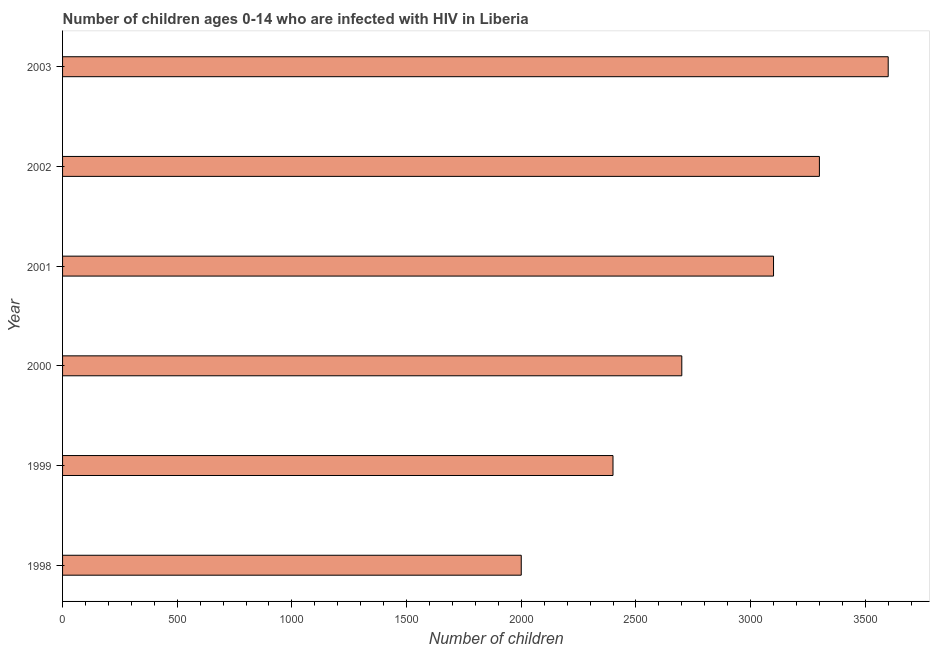Does the graph contain any zero values?
Make the answer very short. No. What is the title of the graph?
Your answer should be very brief. Number of children ages 0-14 who are infected with HIV in Liberia. What is the label or title of the X-axis?
Your answer should be very brief. Number of children. What is the label or title of the Y-axis?
Provide a short and direct response. Year. Across all years, what is the maximum number of children living with hiv?
Offer a terse response. 3600. Across all years, what is the minimum number of children living with hiv?
Offer a terse response. 2000. In which year was the number of children living with hiv maximum?
Keep it short and to the point. 2003. In which year was the number of children living with hiv minimum?
Keep it short and to the point. 1998. What is the sum of the number of children living with hiv?
Keep it short and to the point. 1.71e+04. What is the difference between the number of children living with hiv in 1999 and 2003?
Offer a terse response. -1200. What is the average number of children living with hiv per year?
Keep it short and to the point. 2850. What is the median number of children living with hiv?
Your answer should be compact. 2900. In how many years, is the number of children living with hiv greater than 900 ?
Offer a terse response. 6. Do a majority of the years between 1998 and 2003 (inclusive) have number of children living with hiv greater than 800 ?
Offer a very short reply. Yes. What is the ratio of the number of children living with hiv in 2002 to that in 2003?
Ensure brevity in your answer.  0.92. Is the number of children living with hiv in 1998 less than that in 2001?
Ensure brevity in your answer.  Yes. Is the difference between the number of children living with hiv in 2001 and 2003 greater than the difference between any two years?
Your answer should be compact. No. What is the difference between the highest and the second highest number of children living with hiv?
Your answer should be compact. 300. What is the difference between the highest and the lowest number of children living with hiv?
Your answer should be compact. 1600. How many bars are there?
Provide a short and direct response. 6. Are all the bars in the graph horizontal?
Your answer should be compact. Yes. Are the values on the major ticks of X-axis written in scientific E-notation?
Keep it short and to the point. No. What is the Number of children of 1998?
Ensure brevity in your answer.  2000. What is the Number of children of 1999?
Make the answer very short. 2400. What is the Number of children in 2000?
Keep it short and to the point. 2700. What is the Number of children in 2001?
Ensure brevity in your answer.  3100. What is the Number of children in 2002?
Provide a short and direct response. 3300. What is the Number of children of 2003?
Offer a terse response. 3600. What is the difference between the Number of children in 1998 and 1999?
Offer a very short reply. -400. What is the difference between the Number of children in 1998 and 2000?
Your answer should be very brief. -700. What is the difference between the Number of children in 1998 and 2001?
Offer a very short reply. -1100. What is the difference between the Number of children in 1998 and 2002?
Your answer should be compact. -1300. What is the difference between the Number of children in 1998 and 2003?
Offer a terse response. -1600. What is the difference between the Number of children in 1999 and 2000?
Provide a short and direct response. -300. What is the difference between the Number of children in 1999 and 2001?
Give a very brief answer. -700. What is the difference between the Number of children in 1999 and 2002?
Provide a succinct answer. -900. What is the difference between the Number of children in 1999 and 2003?
Ensure brevity in your answer.  -1200. What is the difference between the Number of children in 2000 and 2001?
Provide a succinct answer. -400. What is the difference between the Number of children in 2000 and 2002?
Give a very brief answer. -600. What is the difference between the Number of children in 2000 and 2003?
Provide a succinct answer. -900. What is the difference between the Number of children in 2001 and 2002?
Offer a very short reply. -200. What is the difference between the Number of children in 2001 and 2003?
Your response must be concise. -500. What is the difference between the Number of children in 2002 and 2003?
Your answer should be very brief. -300. What is the ratio of the Number of children in 1998 to that in 1999?
Keep it short and to the point. 0.83. What is the ratio of the Number of children in 1998 to that in 2000?
Offer a very short reply. 0.74. What is the ratio of the Number of children in 1998 to that in 2001?
Your answer should be compact. 0.65. What is the ratio of the Number of children in 1998 to that in 2002?
Offer a terse response. 0.61. What is the ratio of the Number of children in 1998 to that in 2003?
Your answer should be compact. 0.56. What is the ratio of the Number of children in 1999 to that in 2000?
Offer a terse response. 0.89. What is the ratio of the Number of children in 1999 to that in 2001?
Keep it short and to the point. 0.77. What is the ratio of the Number of children in 1999 to that in 2002?
Make the answer very short. 0.73. What is the ratio of the Number of children in 1999 to that in 2003?
Your answer should be compact. 0.67. What is the ratio of the Number of children in 2000 to that in 2001?
Your response must be concise. 0.87. What is the ratio of the Number of children in 2000 to that in 2002?
Your answer should be compact. 0.82. What is the ratio of the Number of children in 2000 to that in 2003?
Offer a very short reply. 0.75. What is the ratio of the Number of children in 2001 to that in 2002?
Provide a short and direct response. 0.94. What is the ratio of the Number of children in 2001 to that in 2003?
Your answer should be very brief. 0.86. What is the ratio of the Number of children in 2002 to that in 2003?
Offer a terse response. 0.92. 